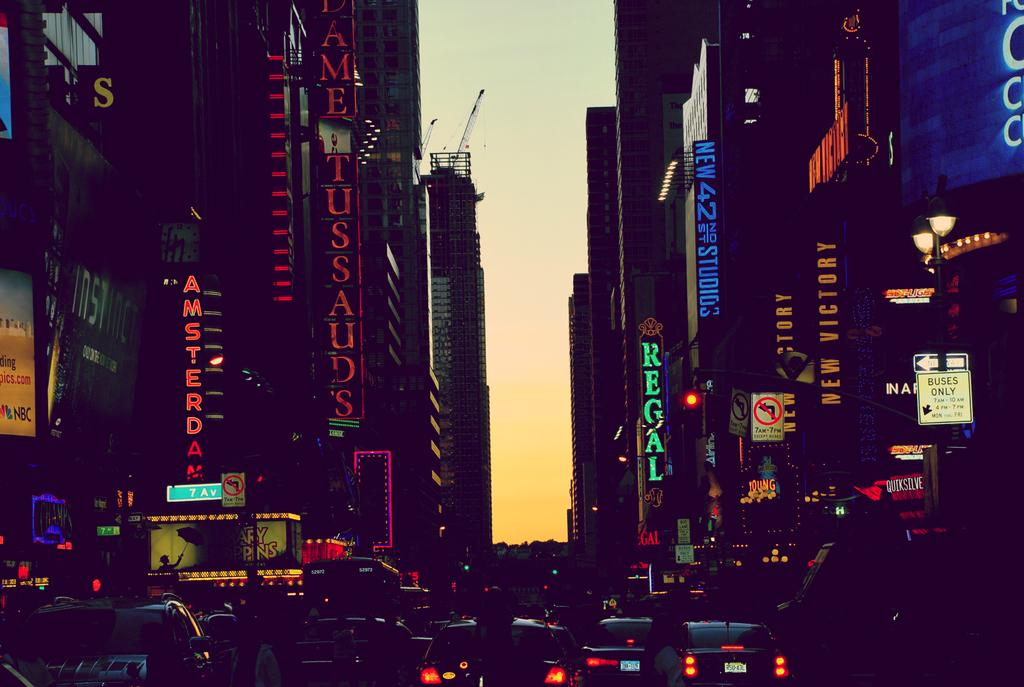What can be seen in the image? There are vehicles in the image. What else is present in the image besides the vehicles? There are buildings with text on the left and right sides of the image. What is visible in the background of the image? The sky is visible in the background of the image. What type of linen is being used to cover the vehicles in the image? There is no linen present in the image, and the vehicles are not covered. 